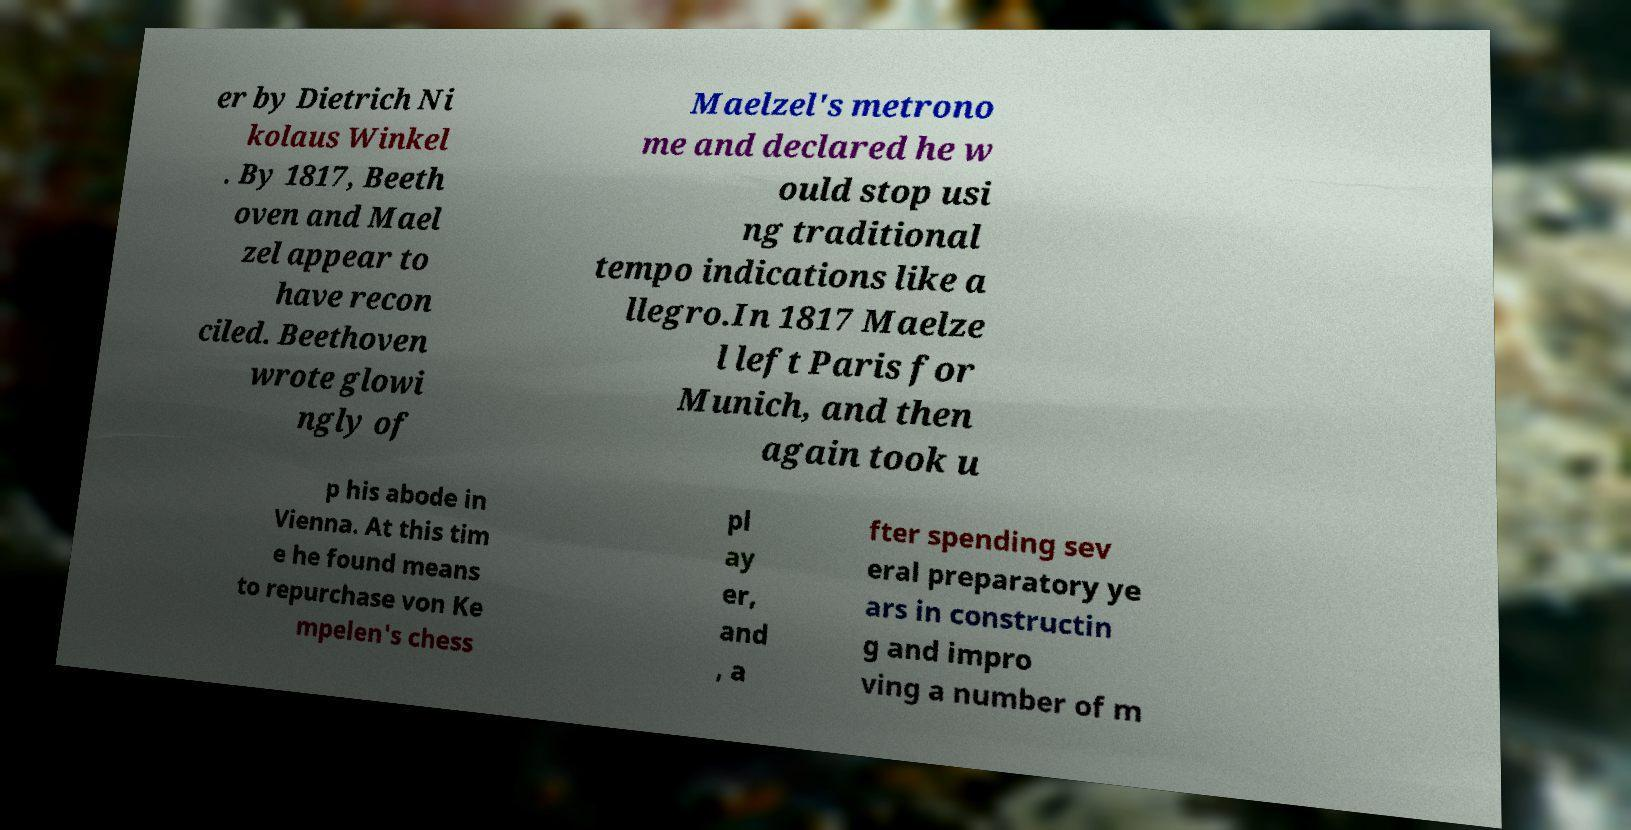Please identify and transcribe the text found in this image. er by Dietrich Ni kolaus Winkel . By 1817, Beeth oven and Mael zel appear to have recon ciled. Beethoven wrote glowi ngly of Maelzel's metrono me and declared he w ould stop usi ng traditional tempo indications like a llegro.In 1817 Maelze l left Paris for Munich, and then again took u p his abode in Vienna. At this tim e he found means to repurchase von Ke mpelen's chess pl ay er, and , a fter spending sev eral preparatory ye ars in constructin g and impro ving a number of m 